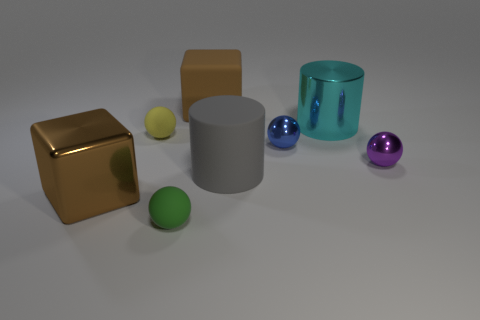How does the lighting in the image affect the perception of the objects? The lighting creates contrast and highlights, accentuating the texture and material differences of the objects. It results in a play of light and shadow that enhances the three-dimensional appearance of the scene. 